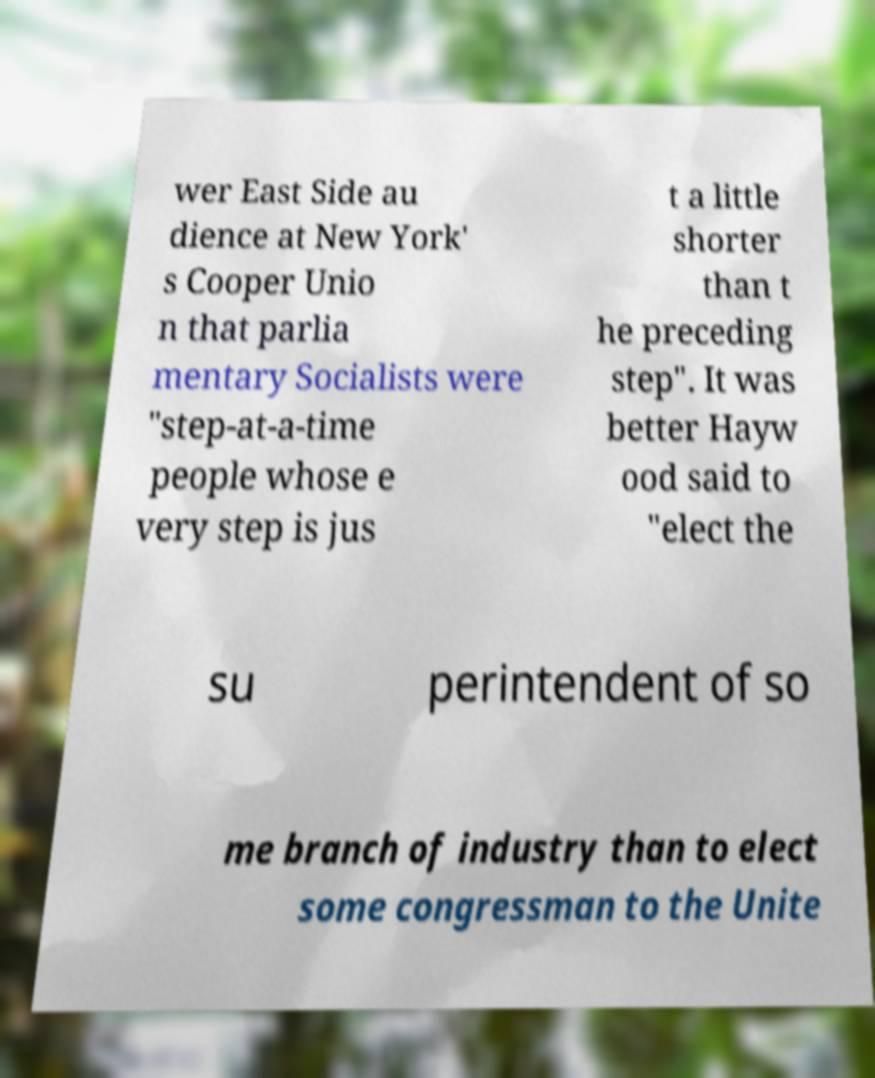What messages or text are displayed in this image? I need them in a readable, typed format. wer East Side au dience at New York' s Cooper Unio n that parlia mentary Socialists were "step-at-a-time people whose e very step is jus t a little shorter than t he preceding step". It was better Hayw ood said to "elect the su perintendent of so me branch of industry than to elect some congressman to the Unite 